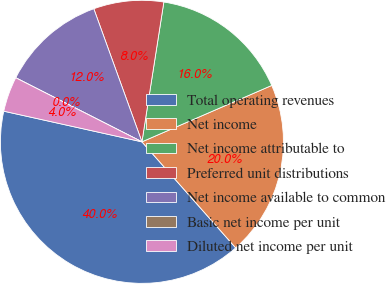Convert chart to OTSL. <chart><loc_0><loc_0><loc_500><loc_500><pie_chart><fcel>Total operating revenues<fcel>Net income<fcel>Net income attributable to<fcel>Preferred unit distributions<fcel>Net income available to common<fcel>Basic net income per unit<fcel>Diluted net income per unit<nl><fcel>40.0%<fcel>20.0%<fcel>16.0%<fcel>8.0%<fcel>12.0%<fcel>0.0%<fcel>4.0%<nl></chart> 